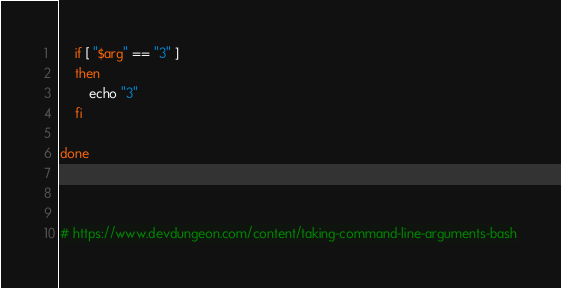<code> <loc_0><loc_0><loc_500><loc_500><_Bash_>
    if [ "$arg" == "3" ] 
    then
        echo "3"
    fi
    
done



# https://www.devdungeon.com/content/taking-command-line-arguments-bash</code> 